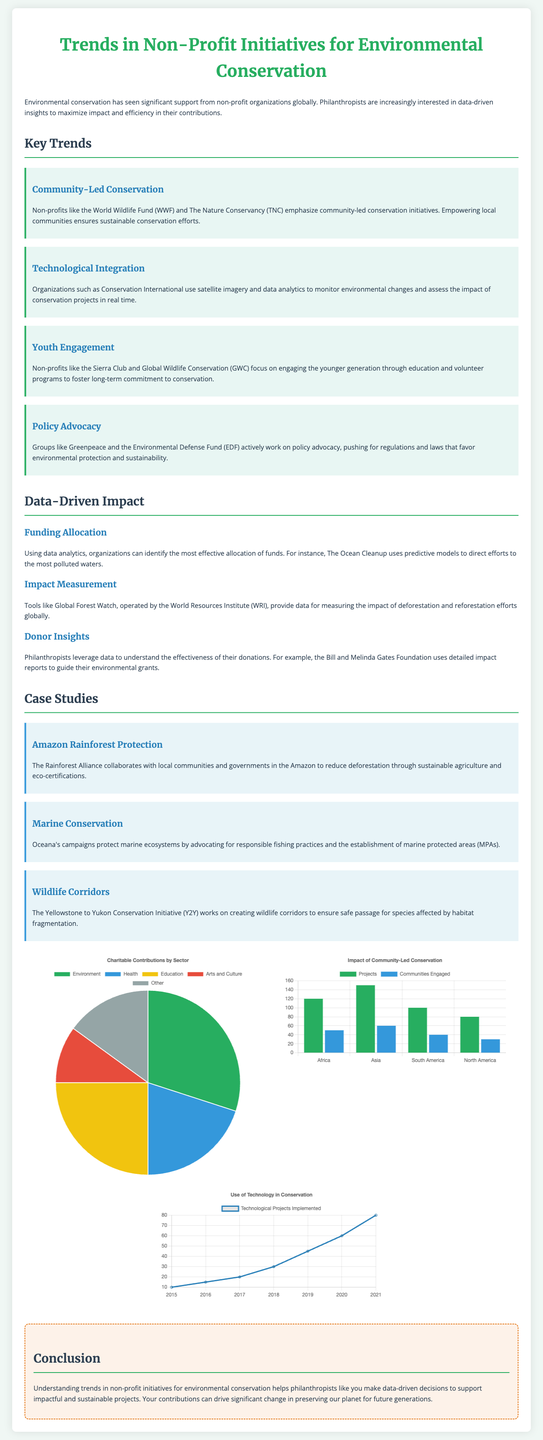What is the title of the document? The title of the document is prominently displayed at the top of the page, indicating its subject matter.
Answer: Trends in Non-Profit Initiatives for Environmental Conservation Which non-profit emphasizes community-led conservation? The document mentions that the World Wildlife Fund (WWF) emphasizes this trend in their initiatives.
Answer: World Wildlife Fund What year saw the greatest number of technological projects implemented? By examining the line chart, we can see which year has the highest data point, indicating the maximum implemented projects.
Answer: 2021 What is the percentage of contributions dedicated to the environment? The pie chart indicates the proportional allocation of charitable contributions by sector, highlighting the specific percentage.
Answer: 30 How many Communities Engaged were reported in South America? The bar chart shows a specific number of engaged communities in South America, which can be directly retrieved from it.
Answer: 40 Which type of conservation initiatives do philanthropists support according to the conclusion? The conclusion summarizes the notion of philanthropy's focus within conservation efforts.
Answer: Sustainable projects What is the trend depicted in the chart titled "Impact of Community-Led Conservation"? The chart illustrates the comparison between two key indicators, projects and communities across regions.
Answer: Projects and Communities Engaged Which organization uses satellite imagery for monitoring? The document specifically mentions one organization that utilizes advanced technology for tracking conservation efforts.
Answer: Conservation International 